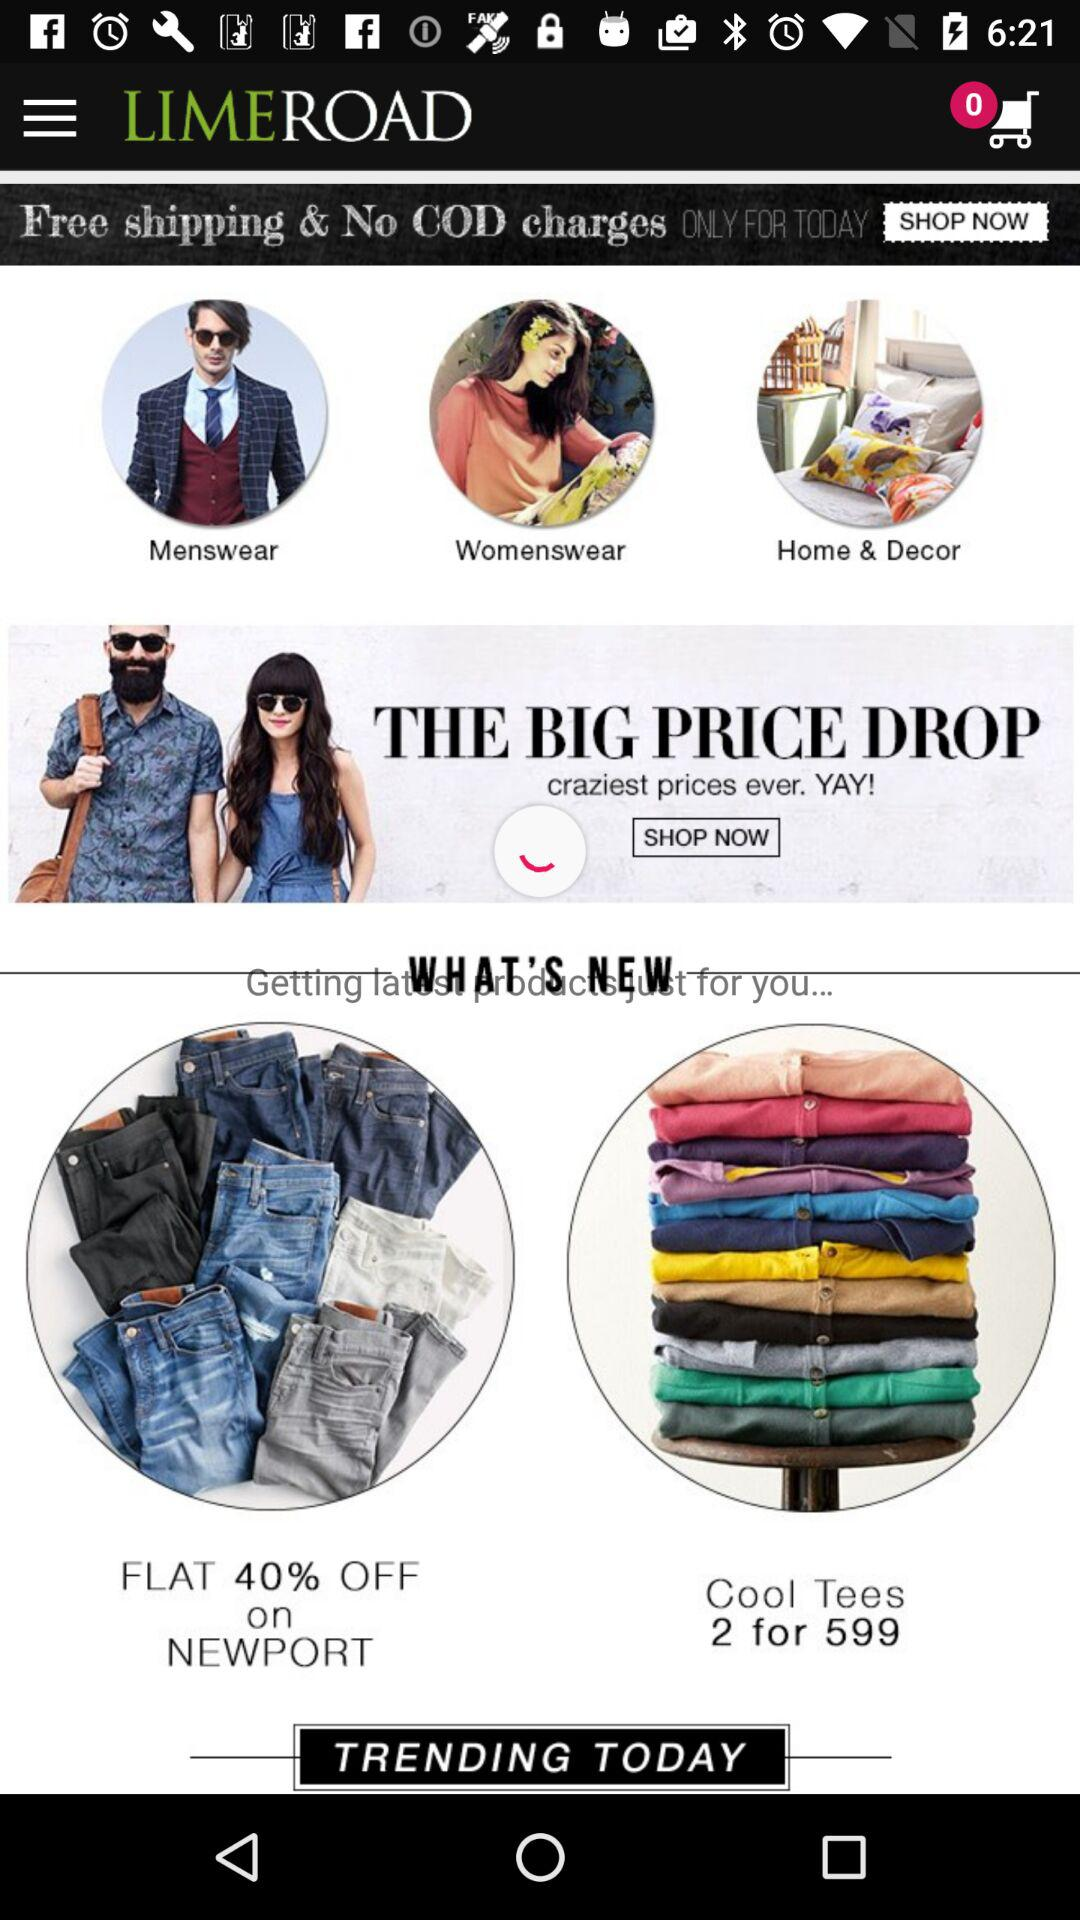What is the price of 2 tees? The price of 2 tees is 599. 